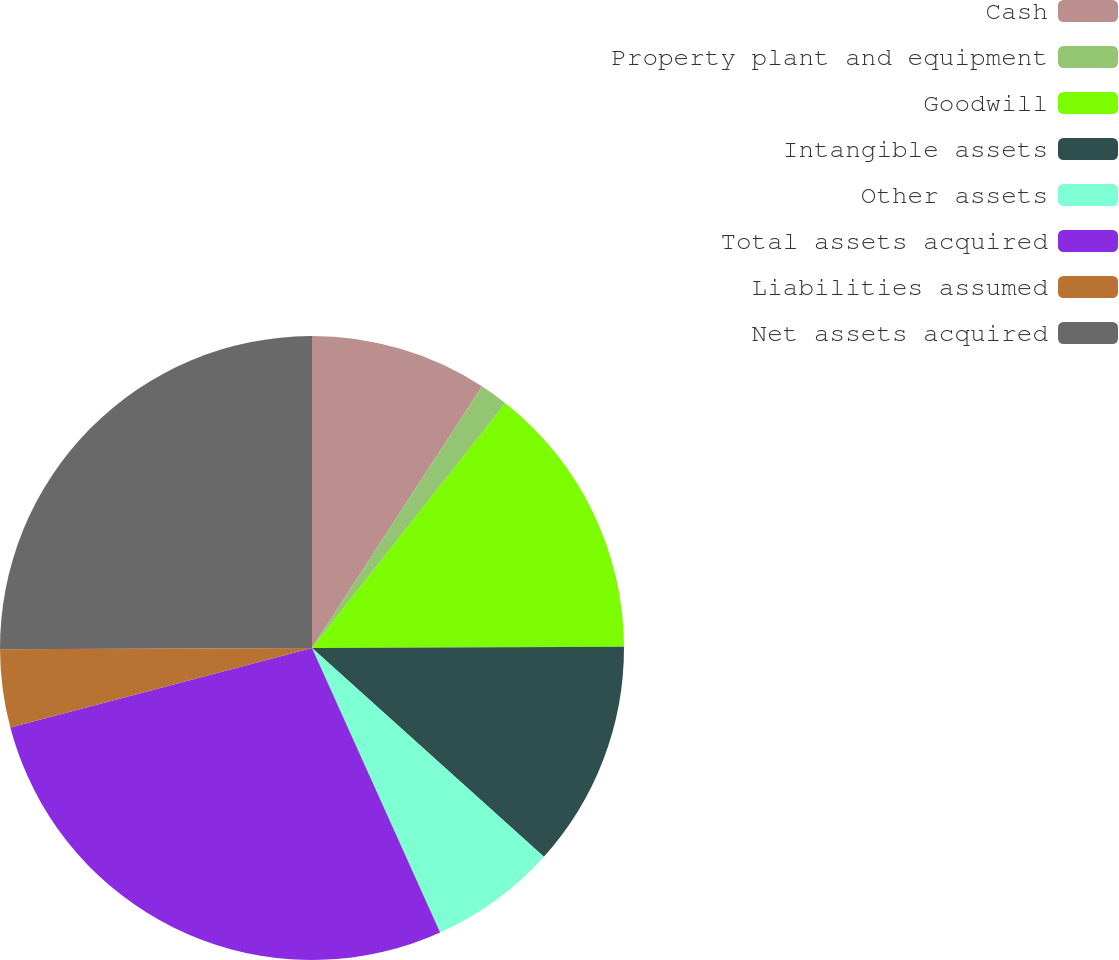Convert chart to OTSL. <chart><loc_0><loc_0><loc_500><loc_500><pie_chart><fcel>Cash<fcel>Property plant and equipment<fcel>Goodwill<fcel>Intangible assets<fcel>Other assets<fcel>Total assets acquired<fcel>Liabilities assumed<fcel>Net assets acquired<nl><fcel>9.17%<fcel>1.47%<fcel>14.3%<fcel>11.73%<fcel>6.6%<fcel>27.63%<fcel>4.04%<fcel>25.07%<nl></chart> 